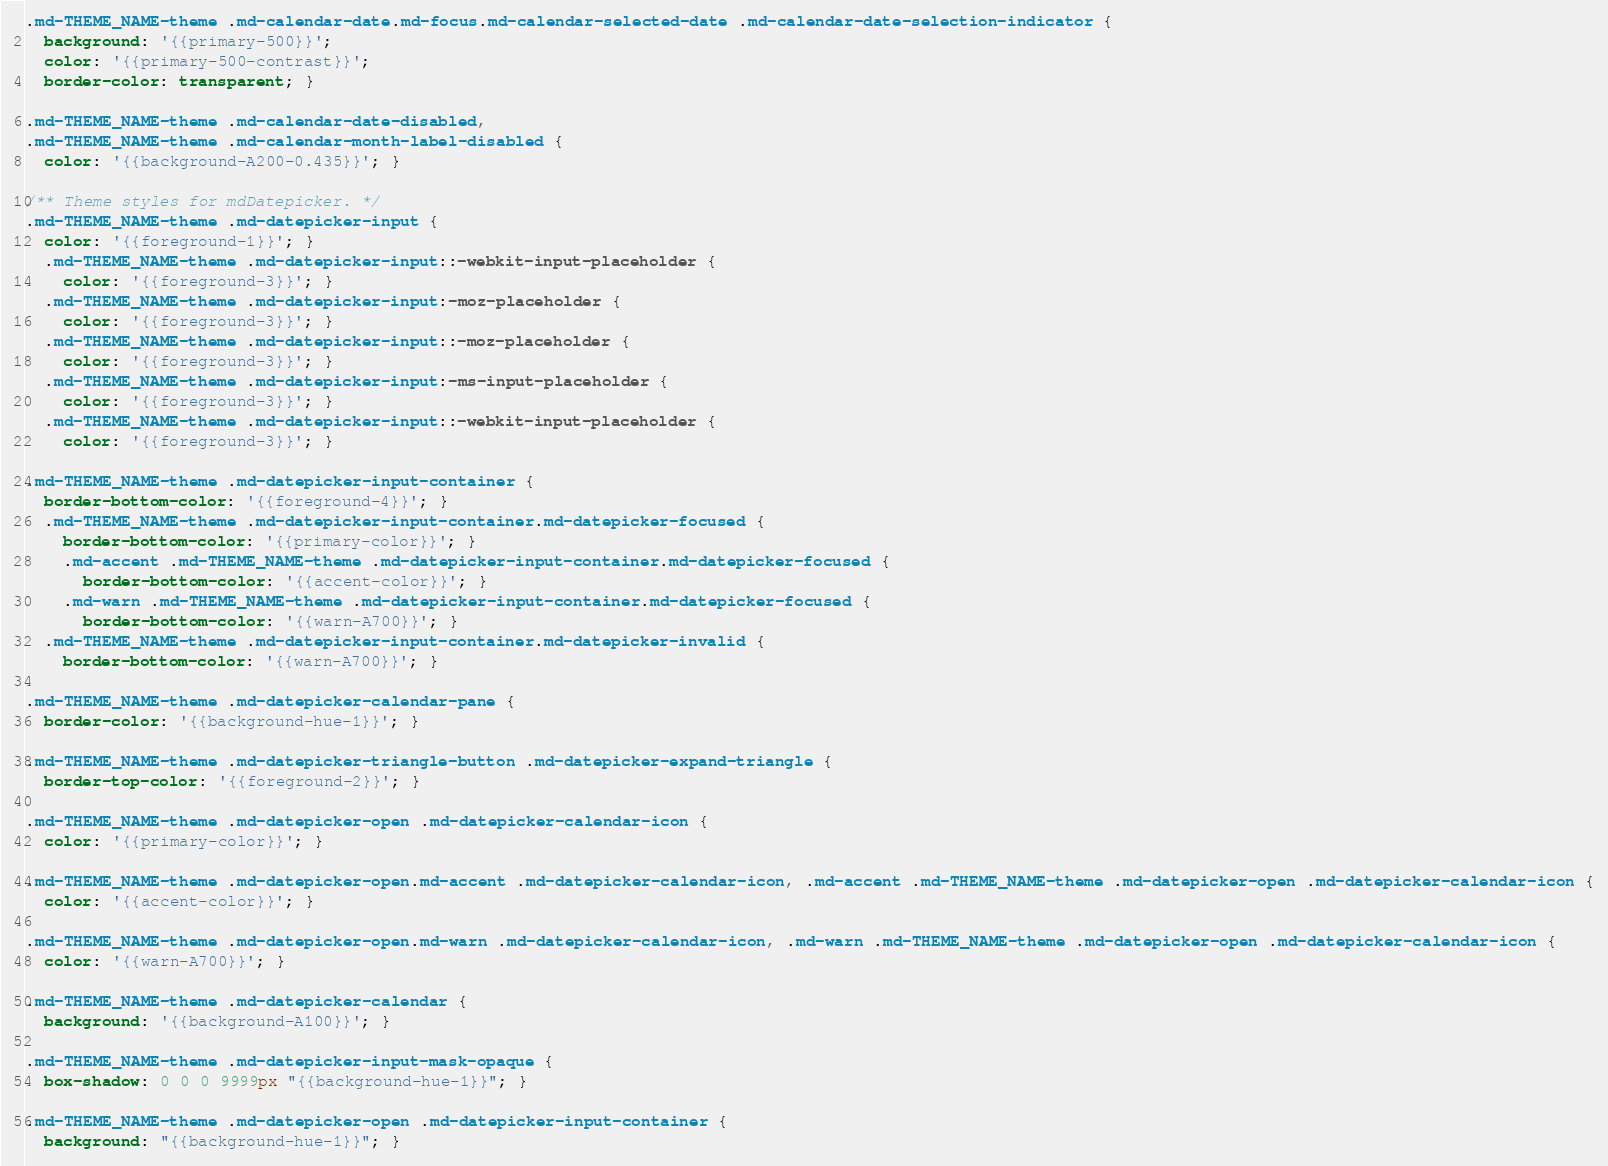<code> <loc_0><loc_0><loc_500><loc_500><_CSS_>.md-THEME_NAME-theme .md-calendar-date.md-focus.md-calendar-selected-date .md-calendar-date-selection-indicator {
  background: '{{primary-500}}';
  color: '{{primary-500-contrast}}';
  border-color: transparent; }

.md-THEME_NAME-theme .md-calendar-date-disabled,
.md-THEME_NAME-theme .md-calendar-month-label-disabled {
  color: '{{background-A200-0.435}}'; }

/** Theme styles for mdDatepicker. */
.md-THEME_NAME-theme .md-datepicker-input {
  color: '{{foreground-1}}'; }
  .md-THEME_NAME-theme .md-datepicker-input::-webkit-input-placeholder {
    color: '{{foreground-3}}'; }
  .md-THEME_NAME-theme .md-datepicker-input:-moz-placeholder {
    color: '{{foreground-3}}'; }
  .md-THEME_NAME-theme .md-datepicker-input::-moz-placeholder {
    color: '{{foreground-3}}'; }
  .md-THEME_NAME-theme .md-datepicker-input:-ms-input-placeholder {
    color: '{{foreground-3}}'; }
  .md-THEME_NAME-theme .md-datepicker-input::-webkit-input-placeholder {
    color: '{{foreground-3}}'; }

.md-THEME_NAME-theme .md-datepicker-input-container {
  border-bottom-color: '{{foreground-4}}'; }
  .md-THEME_NAME-theme .md-datepicker-input-container.md-datepicker-focused {
    border-bottom-color: '{{primary-color}}'; }
    .md-accent .md-THEME_NAME-theme .md-datepicker-input-container.md-datepicker-focused {
      border-bottom-color: '{{accent-color}}'; }
    .md-warn .md-THEME_NAME-theme .md-datepicker-input-container.md-datepicker-focused {
      border-bottom-color: '{{warn-A700}}'; }
  .md-THEME_NAME-theme .md-datepicker-input-container.md-datepicker-invalid {
    border-bottom-color: '{{warn-A700}}'; }

.md-THEME_NAME-theme .md-datepicker-calendar-pane {
  border-color: '{{background-hue-1}}'; }

.md-THEME_NAME-theme .md-datepicker-triangle-button .md-datepicker-expand-triangle {
  border-top-color: '{{foreground-2}}'; }

.md-THEME_NAME-theme .md-datepicker-open .md-datepicker-calendar-icon {
  color: '{{primary-color}}'; }

.md-THEME_NAME-theme .md-datepicker-open.md-accent .md-datepicker-calendar-icon, .md-accent .md-THEME_NAME-theme .md-datepicker-open .md-datepicker-calendar-icon {
  color: '{{accent-color}}'; }

.md-THEME_NAME-theme .md-datepicker-open.md-warn .md-datepicker-calendar-icon, .md-warn .md-THEME_NAME-theme .md-datepicker-open .md-datepicker-calendar-icon {
  color: '{{warn-A700}}'; }

.md-THEME_NAME-theme .md-datepicker-calendar {
  background: '{{background-A100}}'; }

.md-THEME_NAME-theme .md-datepicker-input-mask-opaque {
  box-shadow: 0 0 0 9999px "{{background-hue-1}}"; }

.md-THEME_NAME-theme .md-datepicker-open .md-datepicker-input-container {
  background: "{{background-hue-1}}"; }
</code> 